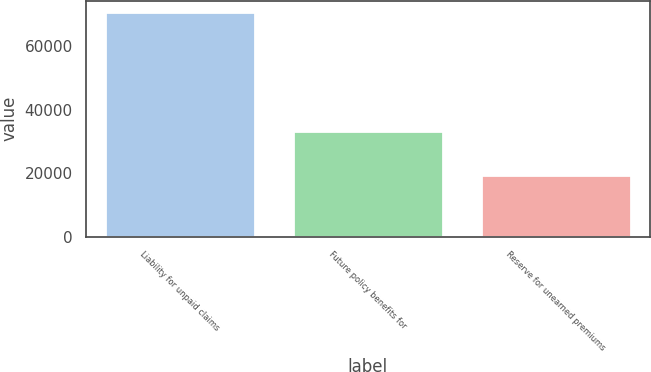Convert chart. <chart><loc_0><loc_0><loc_500><loc_500><bar_chart><fcel>Liability for unpaid claims<fcel>Future policy benefits for<fcel>Reserve for unearned premiums<nl><fcel>70825<fcel>33312<fcel>19553<nl></chart> 